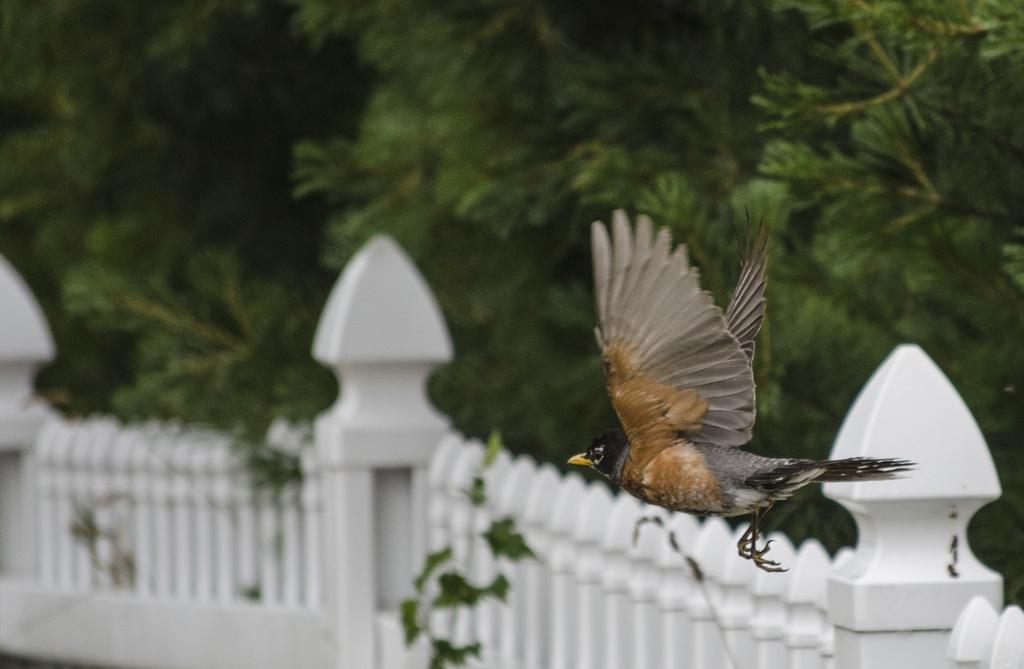What is the bird doing in the image? The bird is flying in the air. What can be seen in the background of the image? There is a fence and trees in the background of the image. How many deer are present in the image? There are no deer present in the image; it only features a bird flying and a fence and trees in the background. 